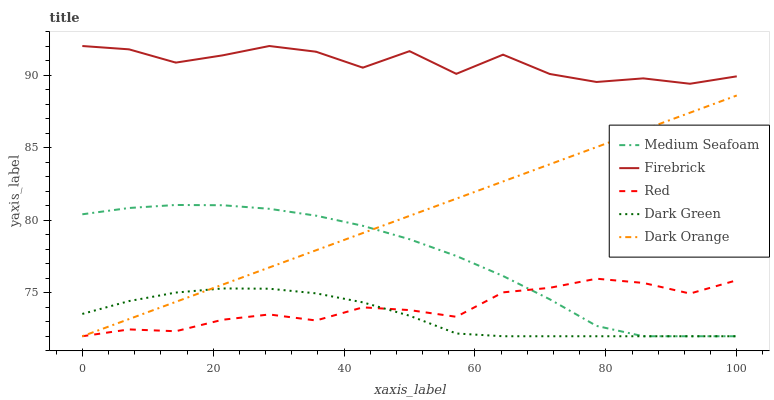Does Medium Seafoam have the minimum area under the curve?
Answer yes or no. No. Does Medium Seafoam have the maximum area under the curve?
Answer yes or no. No. Is Medium Seafoam the smoothest?
Answer yes or no. No. Is Medium Seafoam the roughest?
Answer yes or no. No. Does Firebrick have the lowest value?
Answer yes or no. No. Does Medium Seafoam have the highest value?
Answer yes or no. No. Is Red less than Firebrick?
Answer yes or no. Yes. Is Firebrick greater than Medium Seafoam?
Answer yes or no. Yes. Does Red intersect Firebrick?
Answer yes or no. No. 